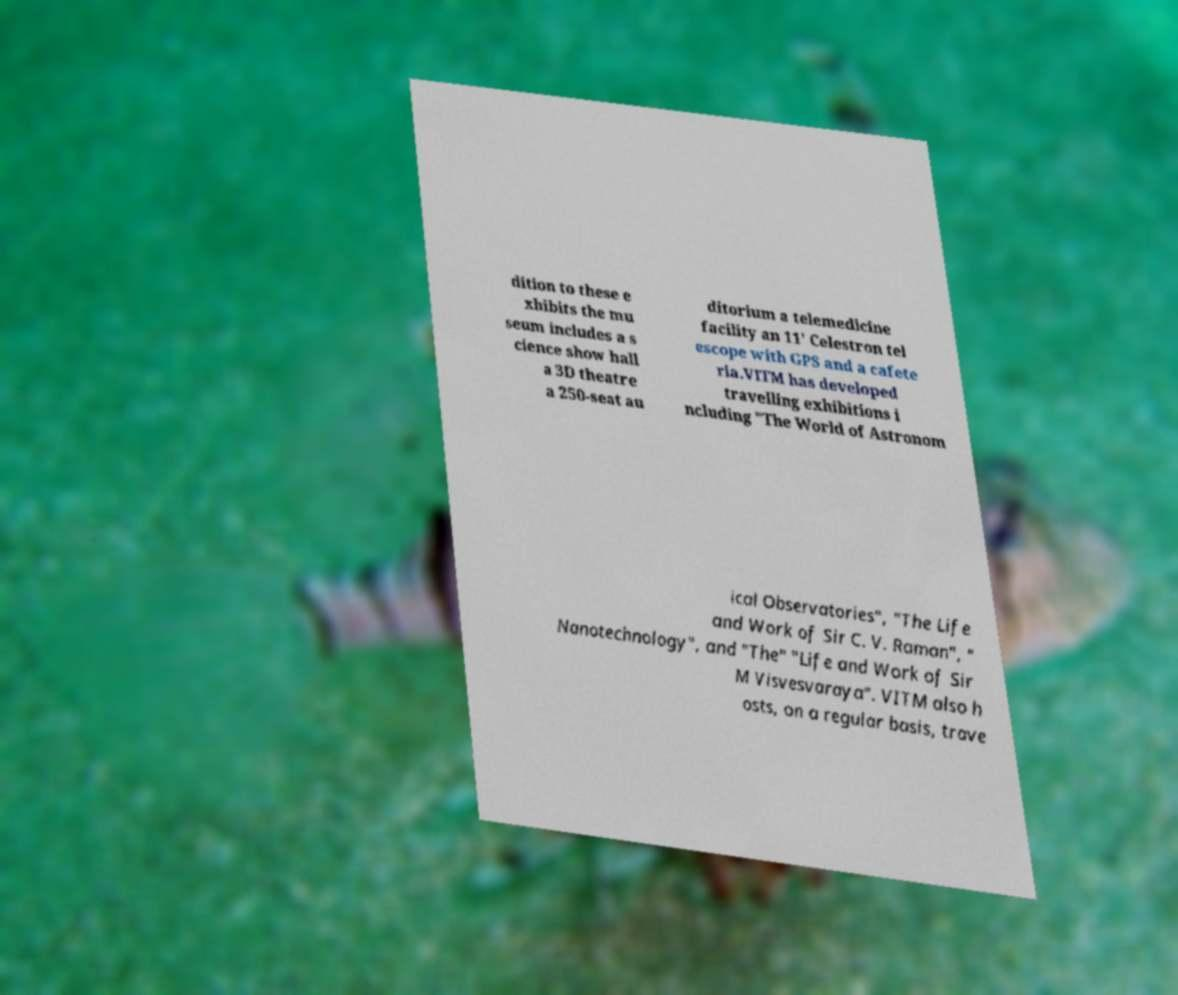Can you accurately transcribe the text from the provided image for me? dition to these e xhibits the mu seum includes a s cience show hall a 3D theatre a 250-seat au ditorium a telemedicine facility an 11' Celestron tel escope with GPS and a cafete ria.VITM has developed travelling exhibitions i ncluding "The World of Astronom ical Observatories", "The Life and Work of Sir C. V. Raman", " Nanotechnology", and "The" "Life and Work of Sir M Visvesvaraya". VITM also h osts, on a regular basis, trave 